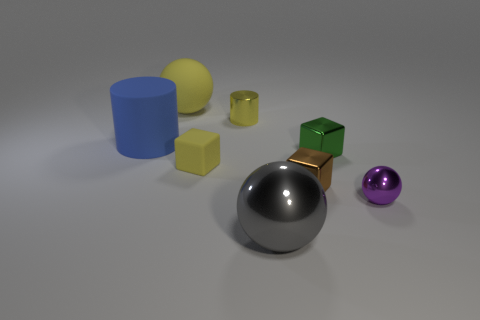There is a small matte thing; does it have the same color as the ball that is on the left side of the tiny yellow metal thing?
Your response must be concise. Yes. Is the blue matte thing the same shape as the purple thing?
Offer a terse response. No. What number of things are rubber objects right of the big rubber sphere or spheres?
Offer a terse response. 4. Is there another tiny object that has the same shape as the tiny brown metallic object?
Your answer should be very brief. Yes. Is the number of small cylinders that are in front of the tiny rubber cube the same as the number of small yellow cubes?
Offer a terse response. No. There is a metallic object that is the same color as the rubber sphere; what is its shape?
Provide a short and direct response. Cylinder. How many blue cylinders are the same size as the gray ball?
Offer a terse response. 1. How many balls are right of the gray shiny object?
Ensure brevity in your answer.  1. What material is the sphere to the right of the large metallic thing to the left of the brown cube?
Ensure brevity in your answer.  Metal. Is there a small matte block of the same color as the big rubber cylinder?
Provide a short and direct response. No. 